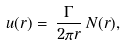<formula> <loc_0><loc_0><loc_500><loc_500>u ( r ) = \, \frac { \Gamma } { 2 \pi r } \, N ( r ) ,</formula> 